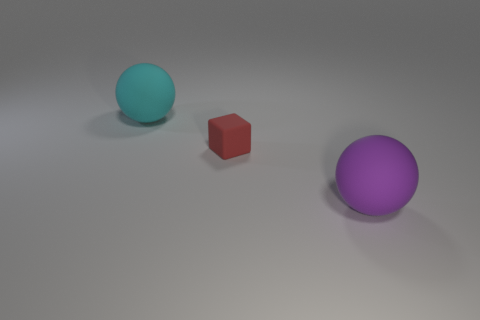Add 1 tiny shiny cylinders. How many objects exist? 4 Subtract all blocks. How many objects are left? 2 Subtract 1 red blocks. How many objects are left? 2 Subtract all big purple rubber spheres. Subtract all tiny brown matte objects. How many objects are left? 2 Add 2 purple rubber spheres. How many purple rubber spheres are left? 3 Add 1 red cylinders. How many red cylinders exist? 1 